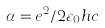<formula> <loc_0><loc_0><loc_500><loc_500>\alpha = e ^ { 2 } / 2 \varepsilon _ { 0 } h c</formula> 